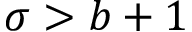<formula> <loc_0><loc_0><loc_500><loc_500>\sigma > b + 1</formula> 